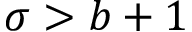<formula> <loc_0><loc_0><loc_500><loc_500>\sigma > b + 1</formula> 